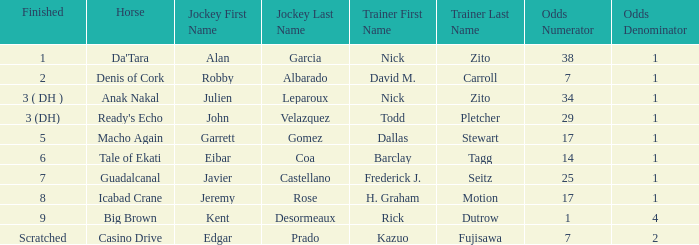Which jockey works with trainer nick zito and has 34-1 odds? Julien Leparoux. 